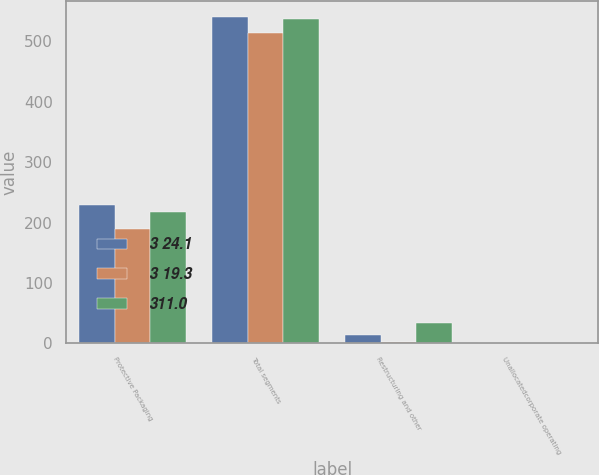<chart> <loc_0><loc_0><loc_500><loc_500><stacked_bar_chart><ecel><fcel>Protective Packaging<fcel>Total segments<fcel>Restructuring and other<fcel>Unallocatedcorporate operating<nl><fcel>3 24.1<fcel>228.7<fcel>539.7<fcel>12.9<fcel>0.7<nl><fcel>3 19.3<fcel>189<fcel>513.1<fcel>1.7<fcel>1<nl><fcel>311.0<fcel>217.6<fcel>536.9<fcel>33<fcel>0.9<nl></chart> 